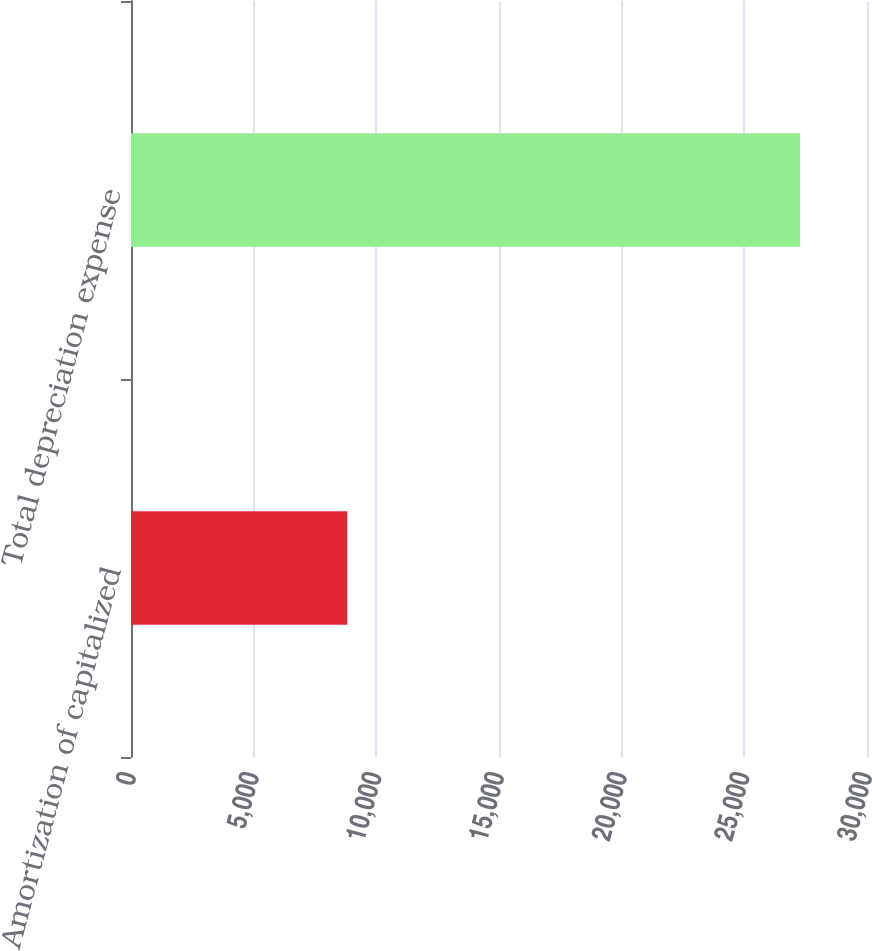Convert chart to OTSL. <chart><loc_0><loc_0><loc_500><loc_500><bar_chart><fcel>Amortization of capitalized<fcel>Total depreciation expense<nl><fcel>8818<fcel>27275<nl></chart> 